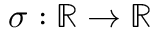Convert formula to latex. <formula><loc_0><loc_0><loc_500><loc_500>\sigma \colon \mathbb { R } \rightarrow \mathbb { R }</formula> 